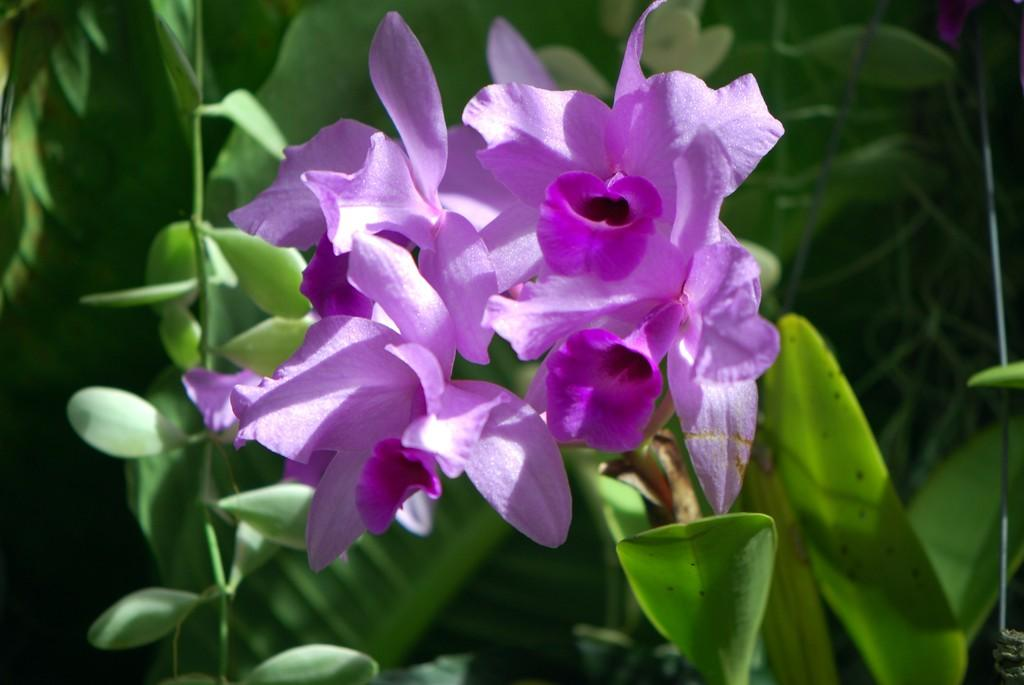What is present in the image? There is a plant in the image. What can be observed about the plant? The plant has flowers. What shape is the discussion taking in the image? There is no discussion present in the image, as it features a plant with flowers. 